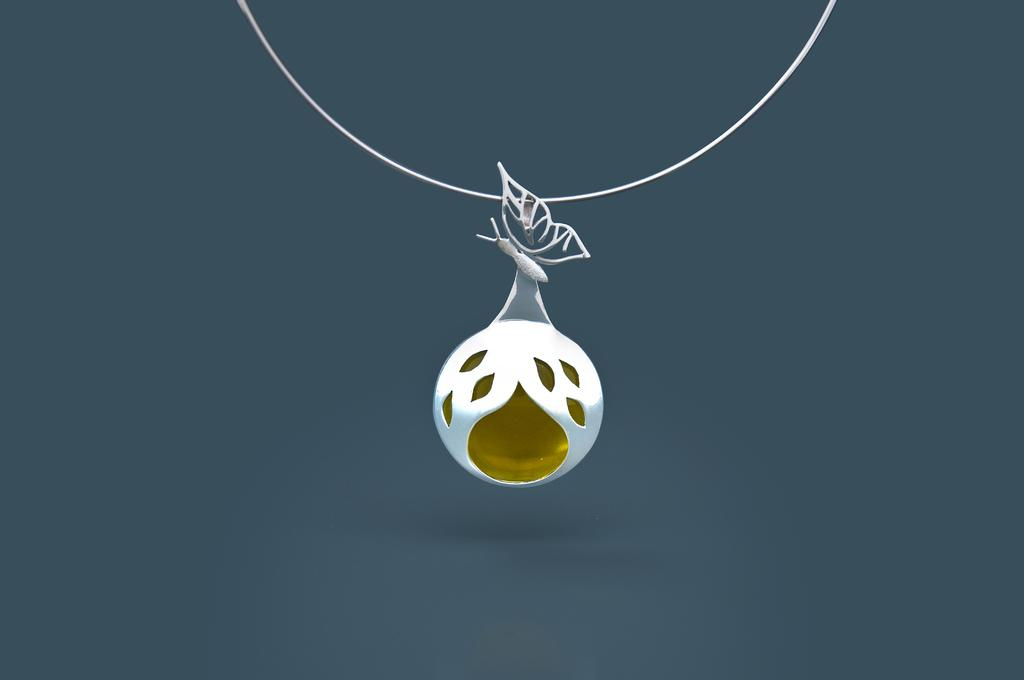What can be seen in the image that resembles a necklace? There is a chain in the image. What is attached to the chain? The chain has a pendant. What shape or design is featured on the pendant? The pendant has a butterfly structure. What beliefs or ideologies are being protested in the image? There is no protest or reference to beliefs in the image; it only features a chain with a pendant that has a butterfly structure. 